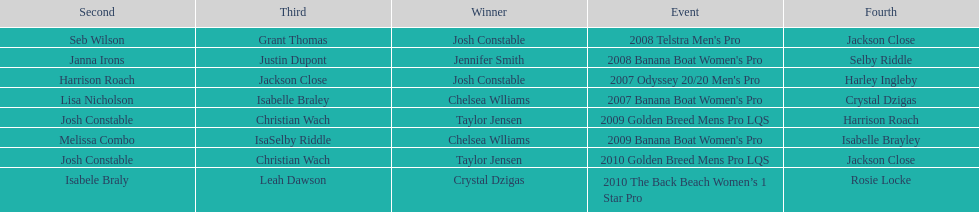What is the total number of times chelsea williams was the winner between 2007 and 2010? 2. Would you be able to parse every entry in this table? {'header': ['Second', 'Third', 'Winner', 'Event', 'Fourth'], 'rows': [['Seb Wilson', 'Grant Thomas', 'Josh Constable', "2008 Telstra Men's Pro", 'Jackson Close'], ['Janna Irons', 'Justin Dupont', 'Jennifer Smith', "2008 Banana Boat Women's Pro", 'Selby Riddle'], ['Harrison Roach', 'Jackson Close', 'Josh Constable', "2007 Odyssey 20/20 Men's Pro", 'Harley Ingleby'], ['Lisa Nicholson', 'Isabelle Braley', 'Chelsea Wlliams', "2007 Banana Boat Women's Pro", 'Crystal Dzigas'], ['Josh Constable', 'Christian Wach', 'Taylor Jensen', '2009 Golden Breed Mens Pro LQS', 'Harrison Roach'], ['Melissa Combo', 'IsaSelby Riddle', 'Chelsea Wlliams', "2009 Banana Boat Women's Pro", 'Isabelle Brayley'], ['Josh Constable', 'Christian Wach', 'Taylor Jensen', '2010 Golden Breed Mens Pro LQS', 'Jackson Close'], ['Isabele Braly', 'Leah Dawson', 'Crystal Dzigas', '2010 The Back Beach Women’s 1 Star Pro', 'Rosie Locke']]} 